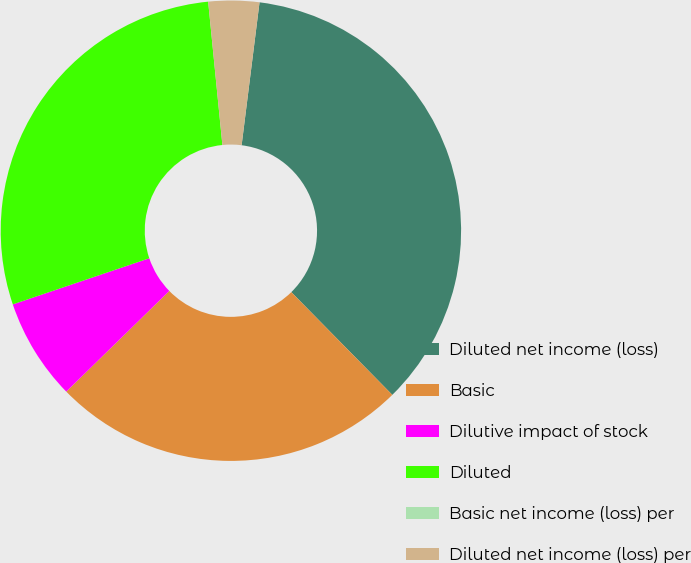Convert chart. <chart><loc_0><loc_0><loc_500><loc_500><pie_chart><fcel>Diluted net income (loss)<fcel>Basic<fcel>Dilutive impact of stock<fcel>Diluted<fcel>Basic net income (loss) per<fcel>Diluted net income (loss) per<nl><fcel>35.65%<fcel>25.05%<fcel>7.13%<fcel>28.61%<fcel>0.0%<fcel>3.56%<nl></chart> 